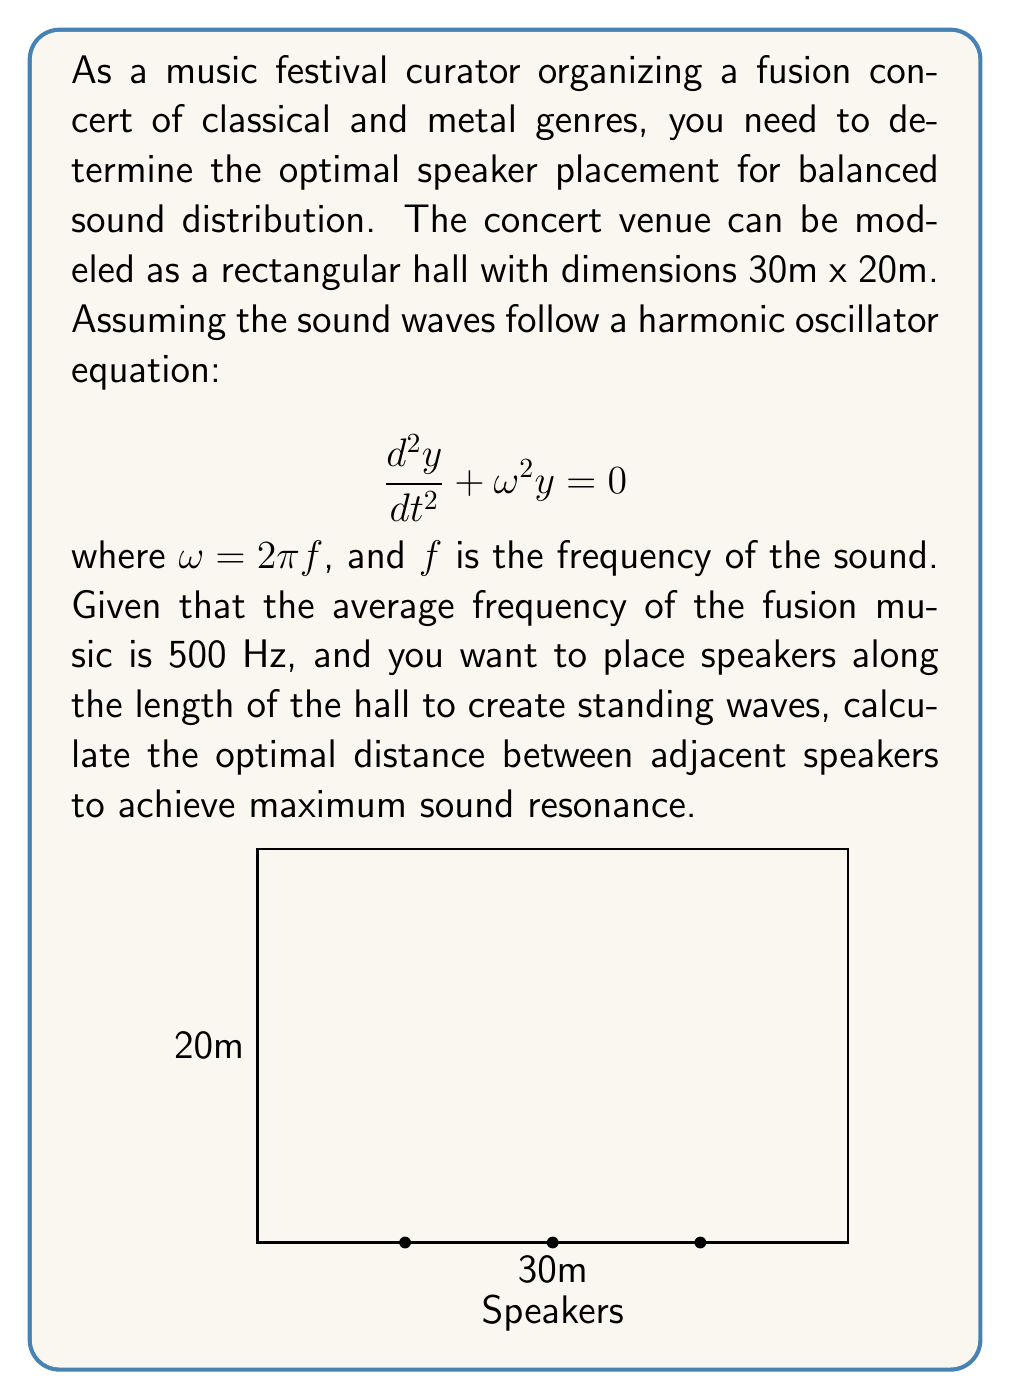Help me with this question. To solve this problem, we'll follow these steps:

1) First, we need to understand that for maximum resonance, we want to create standing waves. The wavelength of a standing wave in a closed system is related to the length of the system.

2) The fundamental wavelength $\lambda$ for a standing wave in a closed system is twice the length of the system. In our case, we want multiple nodes along the length, so we'll use:

   $$L = n\frac{\lambda}{2}$$

   where $L$ is the length of the hall (30m) and $n$ is the number of half-wavelengths.

3) We know the frequency $f = 500$ Hz. We can relate this to wavelength using the speed of sound equation:

   $$v = f\lambda$$

   where $v$ is the speed of sound (approximately 343 m/s at room temperature).

4) Substituting and rearranging:

   $$\lambda = \frac{v}{f} = \frac{343}{500} = 0.686\text{ m}$$

5) Now, we can find $n$ by substituting into our length equation:

   $$30 = n\frac{0.686}{2}$$
   $$n = \frac{60}{0.686} \approx 87.46$$

6) We round this to the nearest whole number, $n = 87$, as we need a whole number of half-wavelengths.

7) The optimal distance between speakers will be one half-wavelength:

   $$\text{Distance} = \frac{\lambda}{2} = \frac{0.686}{2} = 0.343\text{ m}$$

8) To verify, we can calculate how many speakers this would require:

   $$\text{Number of spaces} = \frac{30\text{ m}}{0.343\text{ m}} \approx 87.46$$

   This matches our calculation for $n$, confirming our result.
Answer: 0.343 m 